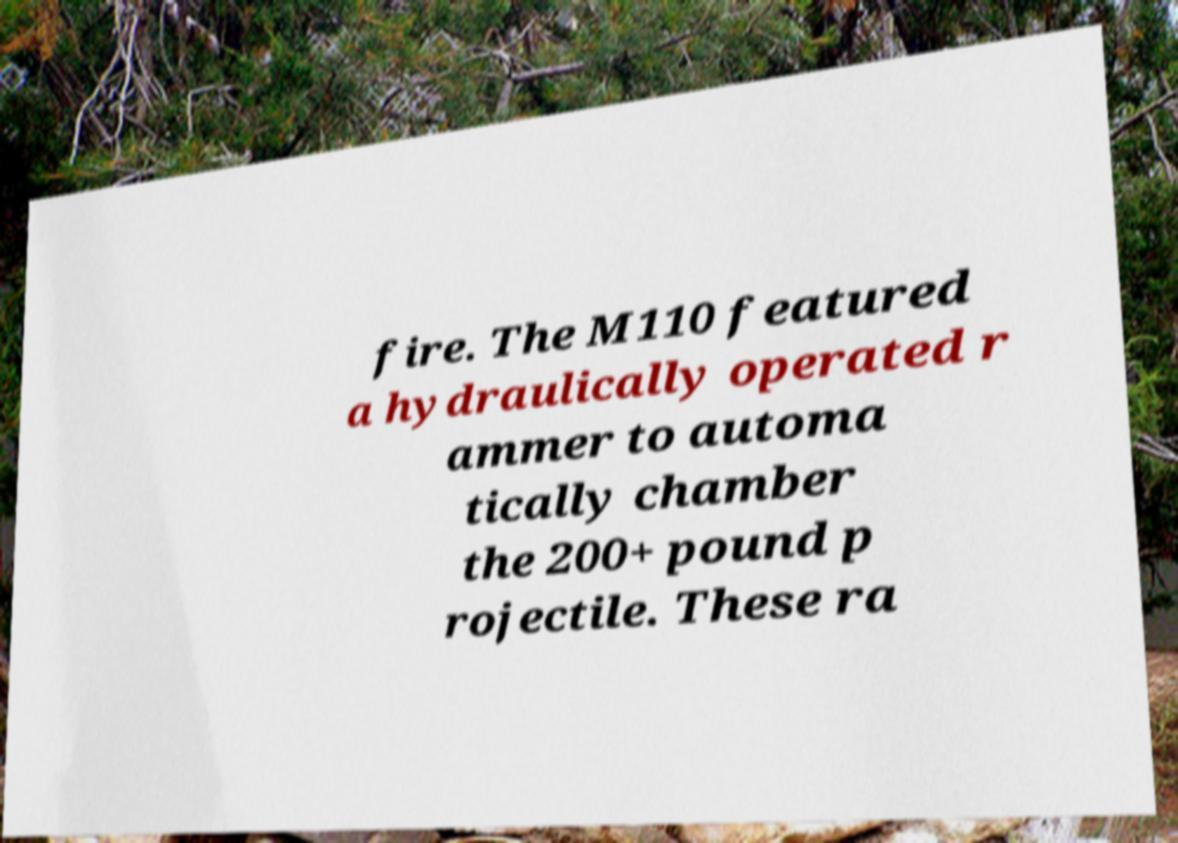For documentation purposes, I need the text within this image transcribed. Could you provide that? fire. The M110 featured a hydraulically operated r ammer to automa tically chamber the 200+ pound p rojectile. These ra 